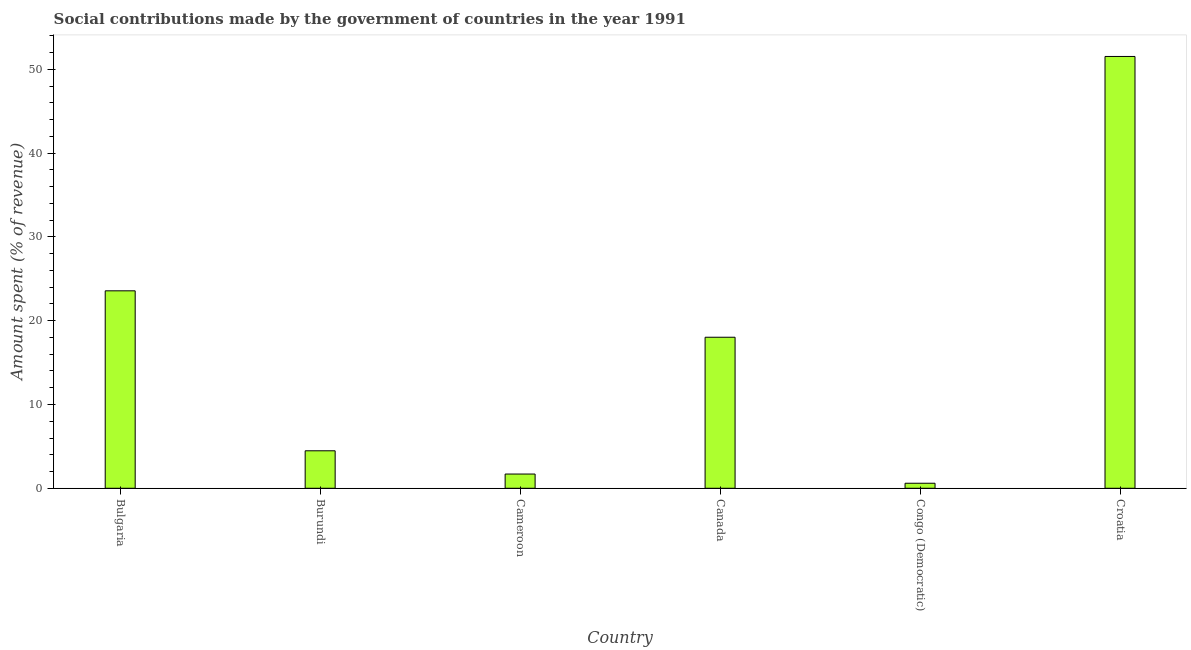Does the graph contain any zero values?
Ensure brevity in your answer.  No. Does the graph contain grids?
Offer a terse response. No. What is the title of the graph?
Keep it short and to the point. Social contributions made by the government of countries in the year 1991. What is the label or title of the X-axis?
Offer a very short reply. Country. What is the label or title of the Y-axis?
Your response must be concise. Amount spent (% of revenue). What is the amount spent in making social contributions in Burundi?
Provide a short and direct response. 4.47. Across all countries, what is the maximum amount spent in making social contributions?
Give a very brief answer. 51.53. Across all countries, what is the minimum amount spent in making social contributions?
Provide a short and direct response. 0.6. In which country was the amount spent in making social contributions maximum?
Ensure brevity in your answer.  Croatia. In which country was the amount spent in making social contributions minimum?
Provide a short and direct response. Congo (Democratic). What is the sum of the amount spent in making social contributions?
Provide a short and direct response. 99.89. What is the difference between the amount spent in making social contributions in Burundi and Cameroon?
Offer a terse response. 2.77. What is the average amount spent in making social contributions per country?
Your response must be concise. 16.65. What is the median amount spent in making social contributions?
Ensure brevity in your answer.  11.25. What is the ratio of the amount spent in making social contributions in Burundi to that in Congo (Democratic)?
Give a very brief answer. 7.43. Is the difference between the amount spent in making social contributions in Bulgaria and Burundi greater than the difference between any two countries?
Make the answer very short. No. What is the difference between the highest and the second highest amount spent in making social contributions?
Offer a terse response. 27.97. Is the sum of the amount spent in making social contributions in Cameroon and Congo (Democratic) greater than the maximum amount spent in making social contributions across all countries?
Keep it short and to the point. No. What is the difference between the highest and the lowest amount spent in making social contributions?
Provide a short and direct response. 50.93. In how many countries, is the amount spent in making social contributions greater than the average amount spent in making social contributions taken over all countries?
Provide a succinct answer. 3. Are all the bars in the graph horizontal?
Provide a succinct answer. No. What is the difference between two consecutive major ticks on the Y-axis?
Provide a short and direct response. 10. Are the values on the major ticks of Y-axis written in scientific E-notation?
Make the answer very short. No. What is the Amount spent (% of revenue) in Bulgaria?
Provide a succinct answer. 23.56. What is the Amount spent (% of revenue) of Burundi?
Offer a terse response. 4.47. What is the Amount spent (% of revenue) of Cameroon?
Offer a terse response. 1.7. What is the Amount spent (% of revenue) of Canada?
Keep it short and to the point. 18.02. What is the Amount spent (% of revenue) in Congo (Democratic)?
Offer a very short reply. 0.6. What is the Amount spent (% of revenue) in Croatia?
Offer a terse response. 51.53. What is the difference between the Amount spent (% of revenue) in Bulgaria and Burundi?
Give a very brief answer. 19.09. What is the difference between the Amount spent (% of revenue) in Bulgaria and Cameroon?
Give a very brief answer. 21.86. What is the difference between the Amount spent (% of revenue) in Bulgaria and Canada?
Ensure brevity in your answer.  5.54. What is the difference between the Amount spent (% of revenue) in Bulgaria and Congo (Democratic)?
Make the answer very short. 22.96. What is the difference between the Amount spent (% of revenue) in Bulgaria and Croatia?
Your answer should be compact. -27.97. What is the difference between the Amount spent (% of revenue) in Burundi and Cameroon?
Make the answer very short. 2.77. What is the difference between the Amount spent (% of revenue) in Burundi and Canada?
Ensure brevity in your answer.  -13.55. What is the difference between the Amount spent (% of revenue) in Burundi and Congo (Democratic)?
Offer a very short reply. 3.87. What is the difference between the Amount spent (% of revenue) in Burundi and Croatia?
Offer a terse response. -47.06. What is the difference between the Amount spent (% of revenue) in Cameroon and Canada?
Your answer should be very brief. -16.33. What is the difference between the Amount spent (% of revenue) in Cameroon and Congo (Democratic)?
Your answer should be compact. 1.1. What is the difference between the Amount spent (% of revenue) in Cameroon and Croatia?
Offer a terse response. -49.83. What is the difference between the Amount spent (% of revenue) in Canada and Congo (Democratic)?
Your answer should be very brief. 17.42. What is the difference between the Amount spent (% of revenue) in Canada and Croatia?
Give a very brief answer. -33.51. What is the difference between the Amount spent (% of revenue) in Congo (Democratic) and Croatia?
Your response must be concise. -50.93. What is the ratio of the Amount spent (% of revenue) in Bulgaria to that in Burundi?
Offer a very short reply. 5.27. What is the ratio of the Amount spent (% of revenue) in Bulgaria to that in Cameroon?
Keep it short and to the point. 13.87. What is the ratio of the Amount spent (% of revenue) in Bulgaria to that in Canada?
Offer a terse response. 1.31. What is the ratio of the Amount spent (% of revenue) in Bulgaria to that in Congo (Democratic)?
Provide a short and direct response. 39.15. What is the ratio of the Amount spent (% of revenue) in Bulgaria to that in Croatia?
Give a very brief answer. 0.46. What is the ratio of the Amount spent (% of revenue) in Burundi to that in Cameroon?
Offer a terse response. 2.63. What is the ratio of the Amount spent (% of revenue) in Burundi to that in Canada?
Your answer should be compact. 0.25. What is the ratio of the Amount spent (% of revenue) in Burundi to that in Congo (Democratic)?
Offer a terse response. 7.43. What is the ratio of the Amount spent (% of revenue) in Burundi to that in Croatia?
Keep it short and to the point. 0.09. What is the ratio of the Amount spent (% of revenue) in Cameroon to that in Canada?
Provide a succinct answer. 0.09. What is the ratio of the Amount spent (% of revenue) in Cameroon to that in Congo (Democratic)?
Make the answer very short. 2.82. What is the ratio of the Amount spent (% of revenue) in Cameroon to that in Croatia?
Provide a succinct answer. 0.03. What is the ratio of the Amount spent (% of revenue) in Canada to that in Congo (Democratic)?
Your answer should be compact. 29.95. What is the ratio of the Amount spent (% of revenue) in Canada to that in Croatia?
Your response must be concise. 0.35. What is the ratio of the Amount spent (% of revenue) in Congo (Democratic) to that in Croatia?
Provide a succinct answer. 0.01. 